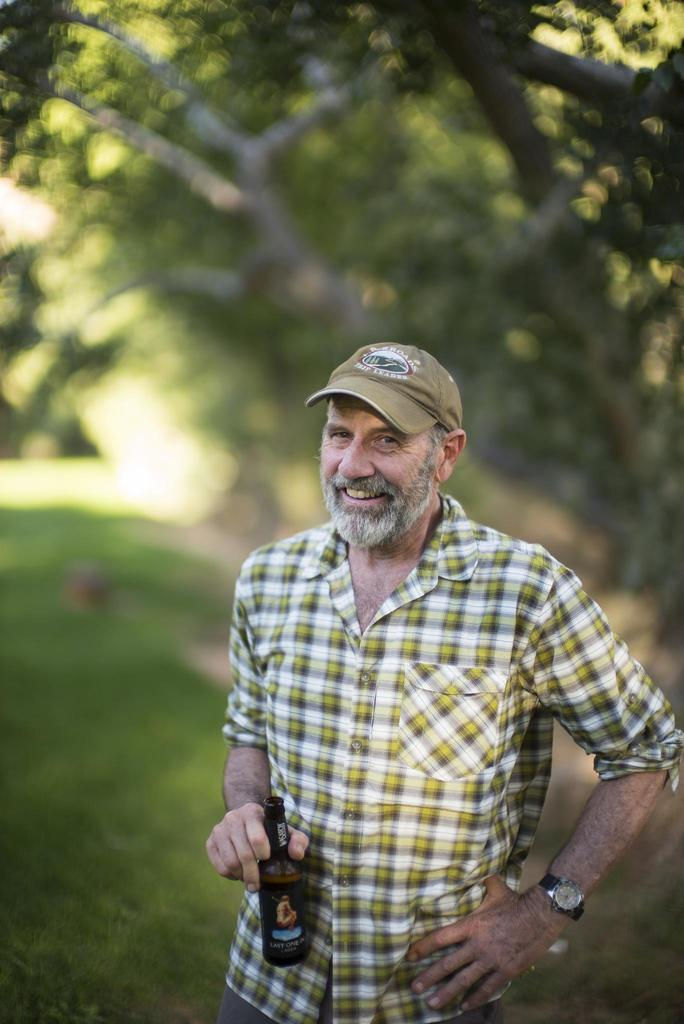What is the main subject of the image? The main subject of the image is a man. What is the man wearing on his head? The man is wearing a cap. What is the man wearing on his wrist? The man is wearing a watch on his hand. What is the man holding in one hand? The man is holding a bottle in one hand. What can be seen in the background of the image? There are trees and grass in the background of the image. How would you describe the background of the image? The background of the image is blurry. What type of liquid is the man pouring out of his toes in the image? There is no liquid or toes visible in the image; the man is holding a bottle in one hand. 